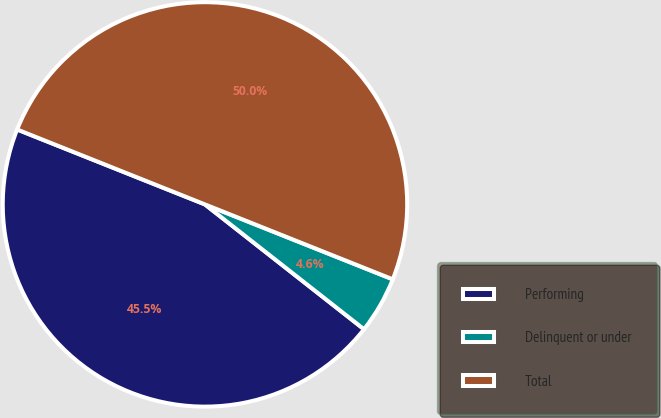Convert chart to OTSL. <chart><loc_0><loc_0><loc_500><loc_500><pie_chart><fcel>Performing<fcel>Delinquent or under<fcel>Total<nl><fcel>45.45%<fcel>4.55%<fcel>50.0%<nl></chart> 